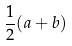Convert formula to latex. <formula><loc_0><loc_0><loc_500><loc_500>\frac { 1 } { 2 } ( a + b )</formula> 